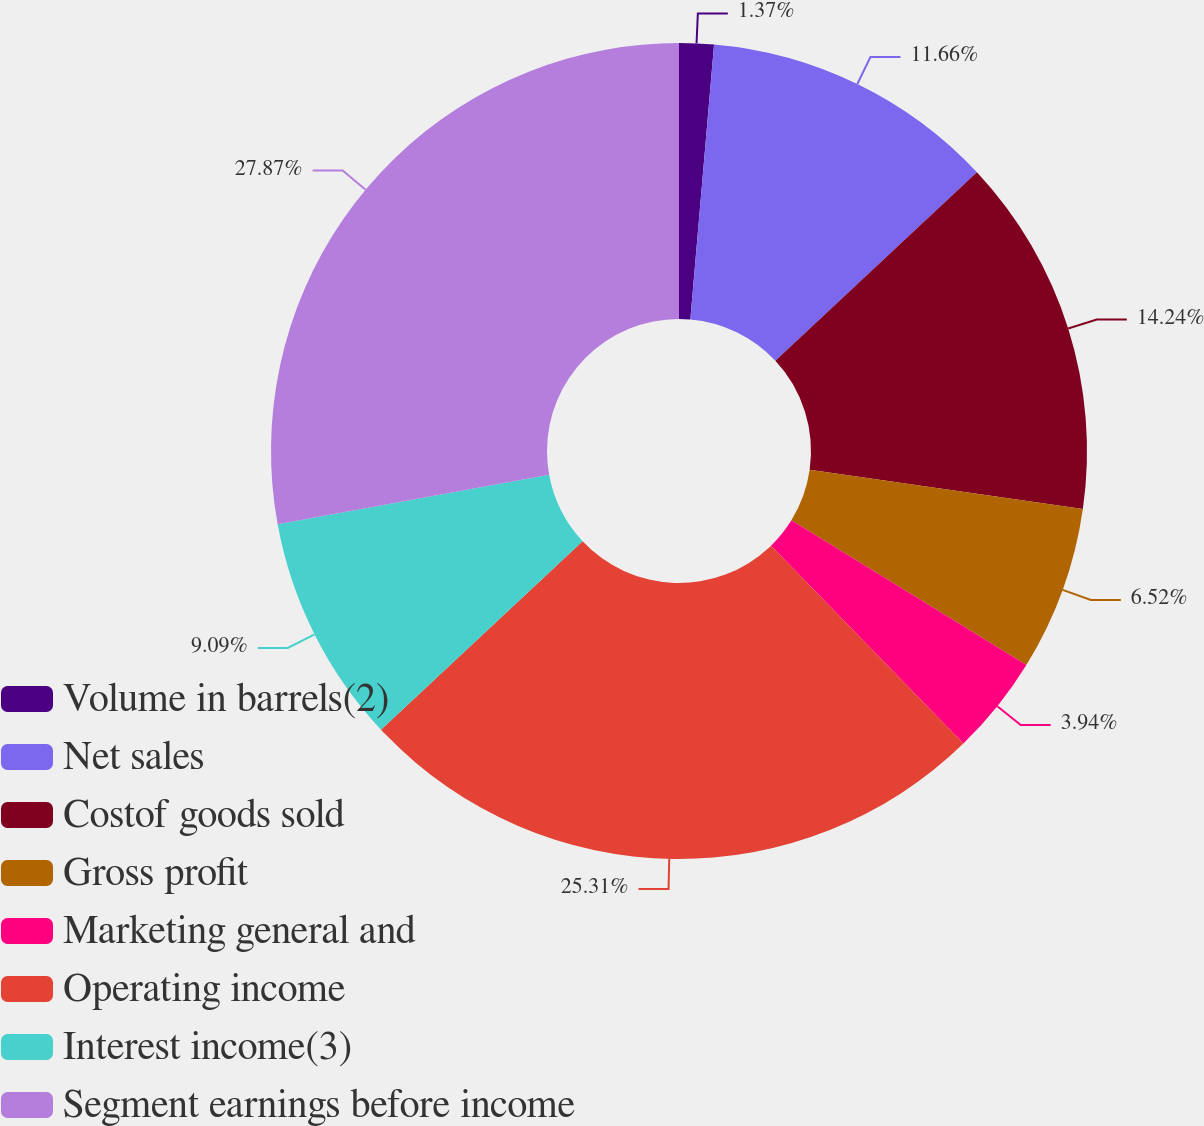<chart> <loc_0><loc_0><loc_500><loc_500><pie_chart><fcel>Volume in barrels(2)<fcel>Net sales<fcel>Costof goods sold<fcel>Gross profit<fcel>Marketing general and<fcel>Operating income<fcel>Interest income(3)<fcel>Segment earnings before income<nl><fcel>1.37%<fcel>11.66%<fcel>14.24%<fcel>6.52%<fcel>3.94%<fcel>25.31%<fcel>9.09%<fcel>27.88%<nl></chart> 